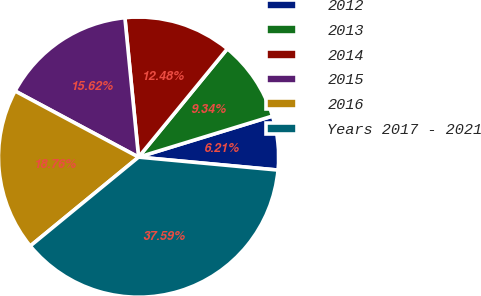<chart> <loc_0><loc_0><loc_500><loc_500><pie_chart><fcel>2012<fcel>2013<fcel>2014<fcel>2015<fcel>2016<fcel>Years 2017 - 2021<nl><fcel>6.21%<fcel>9.34%<fcel>12.48%<fcel>15.62%<fcel>18.76%<fcel>37.59%<nl></chart> 